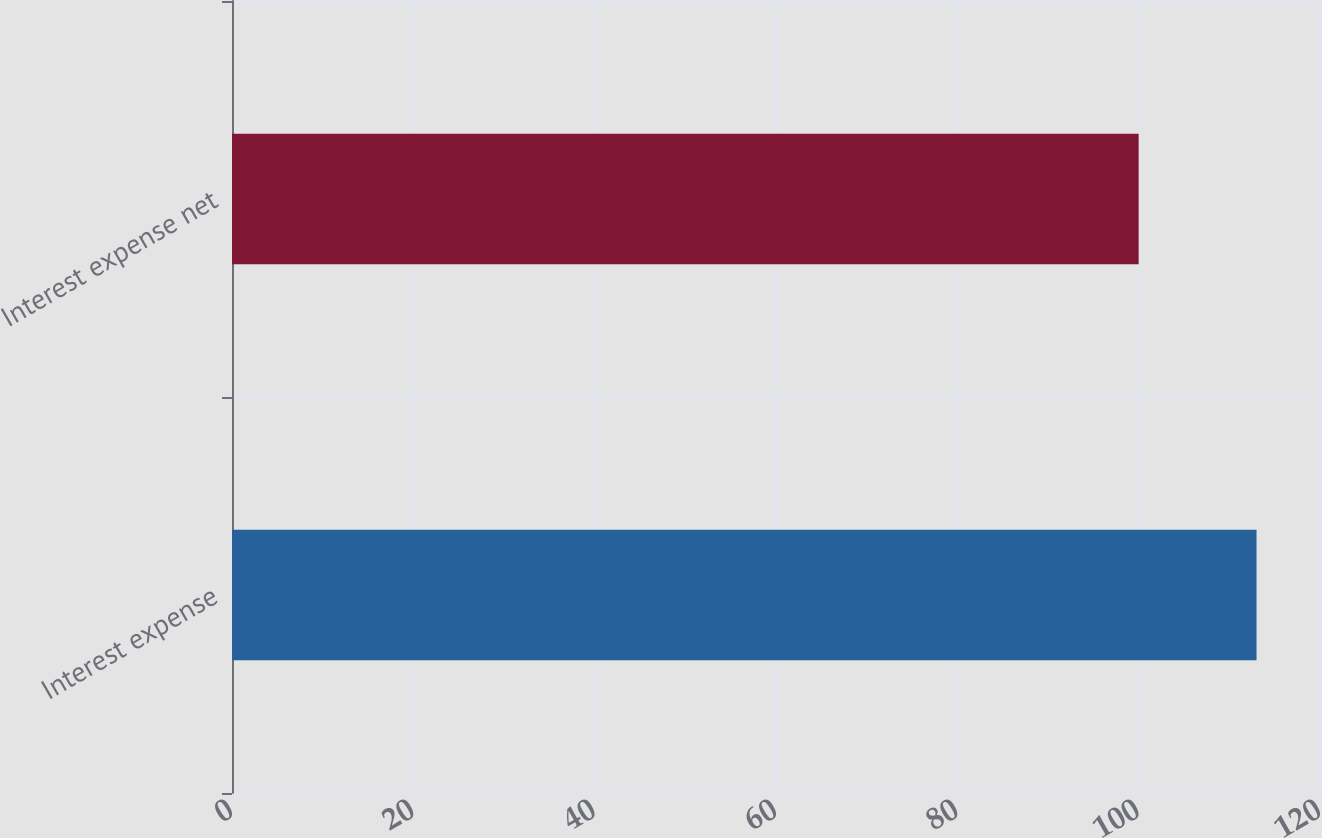Convert chart. <chart><loc_0><loc_0><loc_500><loc_500><bar_chart><fcel>Interest expense<fcel>Interest expense net<nl><fcel>113<fcel>100<nl></chart> 